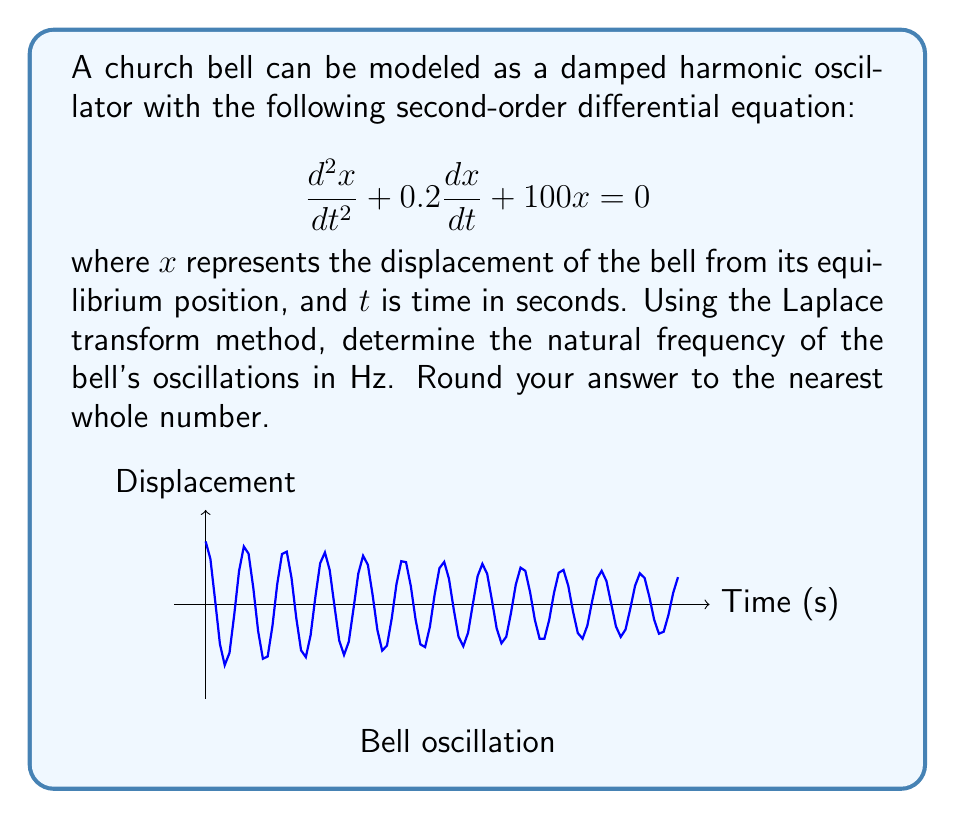Solve this math problem. Let's approach this step-by-step using the Laplace transform method:

1) First, we take the Laplace transform of both sides of the equation:
   $$\mathcal{L}\{\frac{d^2x}{dt^2} + 0.2\frac{dx}{dt} + 100x\} = \mathcal{L}\{0\}$$

2) Using Laplace transform properties:
   $$(s^2X(s) - sx(0) - x'(0)) + 0.2(sX(s) - x(0)) + 100X(s) = 0$$

3) Assume initial conditions $x(0) = 1$ and $x'(0) = 0$ for simplicity:
   $$(s^2X(s) - s) + 0.2(sX(s) - 1) + 100X(s) = 0$$

4) Collect terms with $X(s)$:
   $$X(s)(s^2 + 0.2s + 100) = s + 0.2$$

5) Solve for $X(s)$:
   $$X(s) = \frac{s + 0.2}{s^2 + 0.2s + 100}$$

6) The characteristic equation is $s^2 + 0.2s + 100 = 0$

7) Solve this equation:
   $$s = \frac{-0.2 \pm \sqrt{0.2^2 - 4(100)}}{2} = -0.1 \pm 9.999i$$

8) The complex roots are $s = -0.1 \pm 9.999i$

9) The natural frequency is given by the imaginary part:
   $$\omega_n = 9.999 \text{ rad/s}$$

10) Convert to Hz:
    $$f = \frac{\omega_n}{2\pi} = \frac{9.999}{2\pi} \approx 1.59 \text{ Hz}$$

11) Rounding to the nearest whole number: 2 Hz
Answer: 2 Hz 